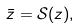Convert formula to latex. <formula><loc_0><loc_0><loc_500><loc_500>\bar { z } = \mathcal { S } ( z ) ,</formula> 